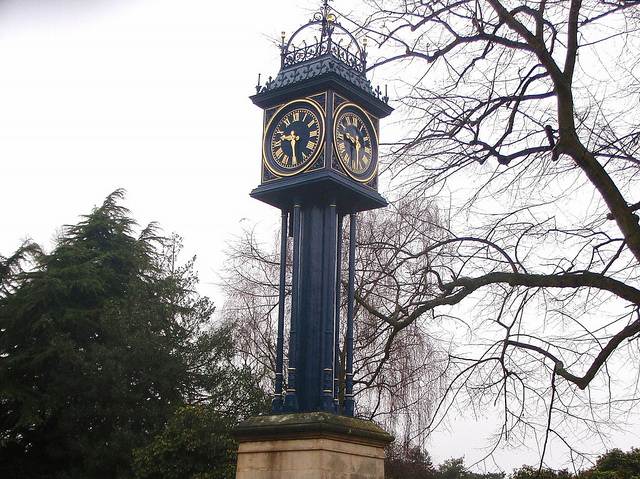What might be the historical significance of this clock? Clocks like this one generally serve as landmarks and can be commemorative in nature. They are commonly erected to mark important events, celebrate community milestones, or honor prominent figures. This clock's grand presence suggests it may have been installed to serve a significant role in the local history or urban landscape. 